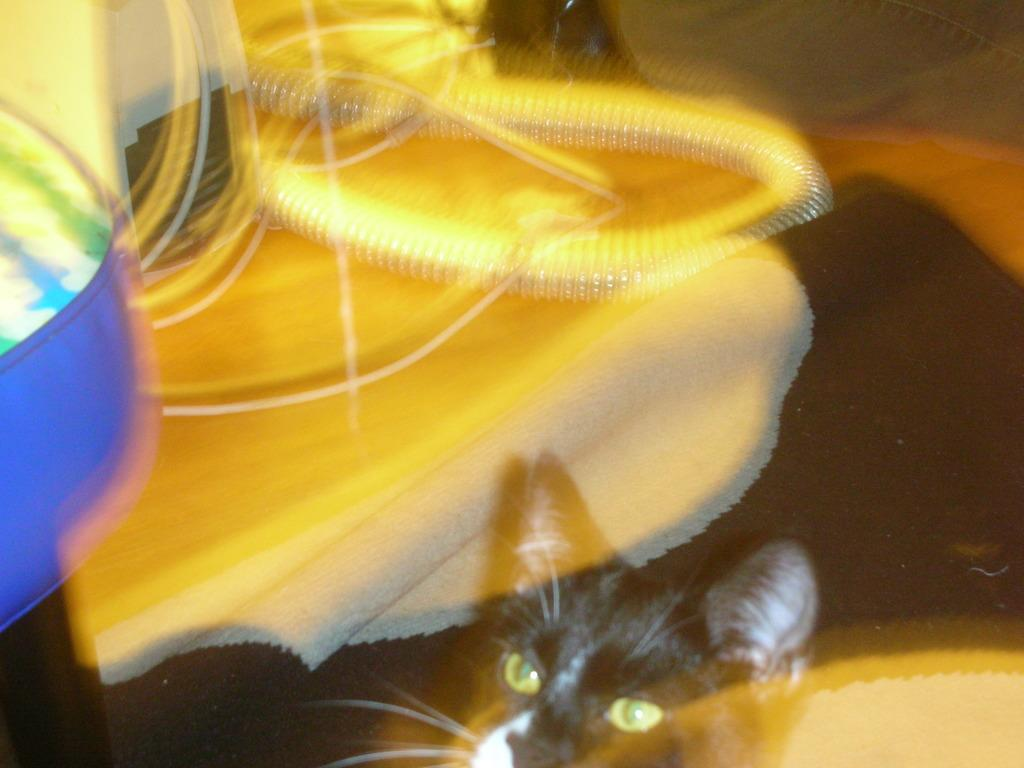What type of animal is in the image? There is a cat in the image. How would you describe the color scheme of the image? The image contains shaded colors. What type of chair is the cat sitting on in the image? There is no chair present in the image; it only features a cat. What achievements has the boot accomplished in the image? There is no boot present in the image, and therefore no achievements can be attributed to it. 